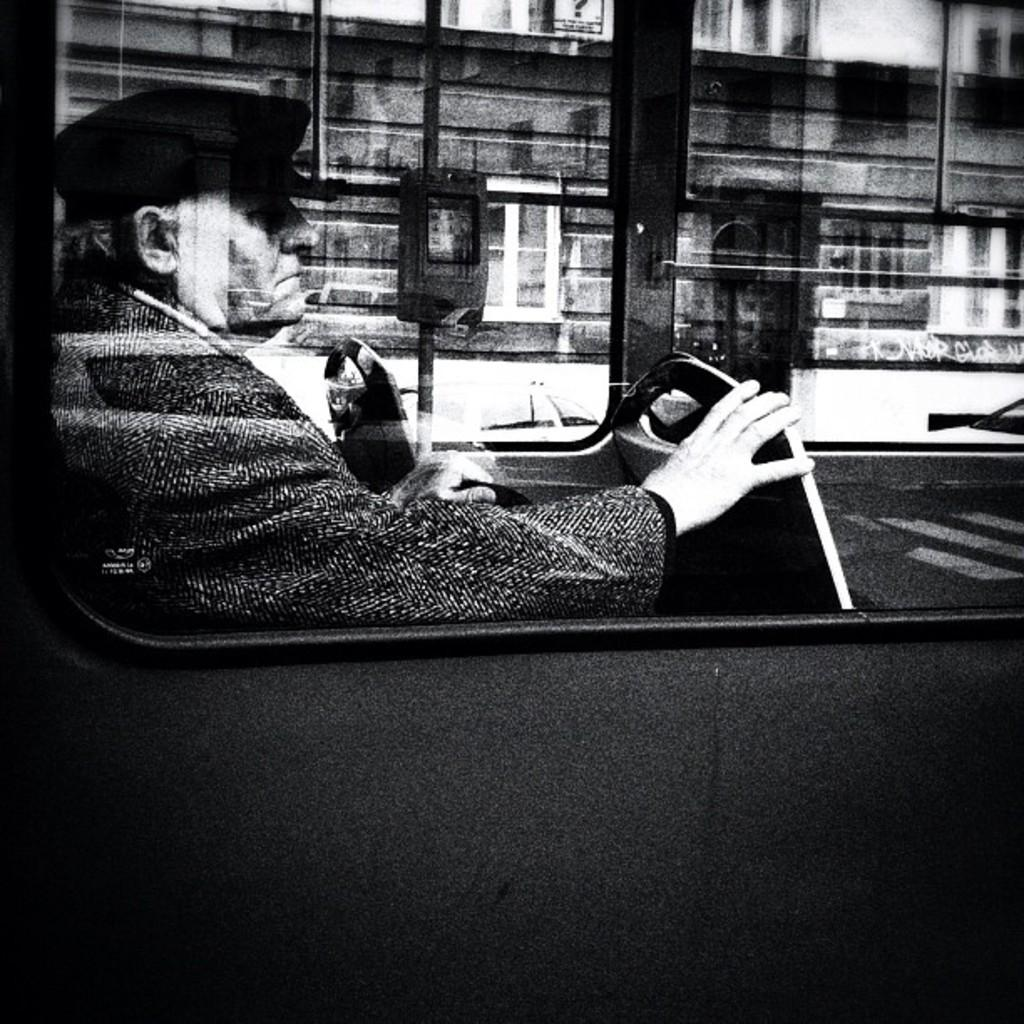What is the color scheme of the image? The image is black and white. What is the man in the image doing? The man is sitting on the seat of a motor vehicle. What type of structures can be seen in the image? There are buildings visible in the image. What else can be seen in the image besides the man and buildings? Street poles are present in the image. What type of beef is being prepared in the image? There is no beef or any indication of food preparation in the image. Can you tell me how many people are taking a bath in the image? There is no bath or any indication of bathing in the image. 